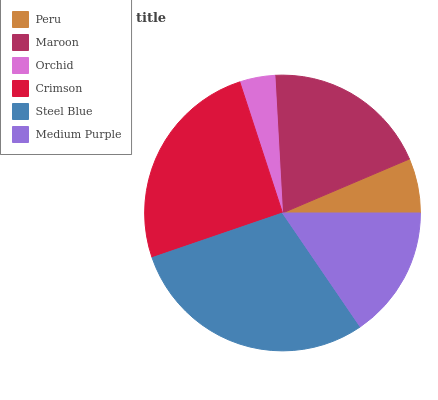Is Orchid the minimum?
Answer yes or no. Yes. Is Steel Blue the maximum?
Answer yes or no. Yes. Is Maroon the minimum?
Answer yes or no. No. Is Maroon the maximum?
Answer yes or no. No. Is Maroon greater than Peru?
Answer yes or no. Yes. Is Peru less than Maroon?
Answer yes or no. Yes. Is Peru greater than Maroon?
Answer yes or no. No. Is Maroon less than Peru?
Answer yes or no. No. Is Maroon the high median?
Answer yes or no. Yes. Is Medium Purple the low median?
Answer yes or no. Yes. Is Steel Blue the high median?
Answer yes or no. No. Is Peru the low median?
Answer yes or no. No. 